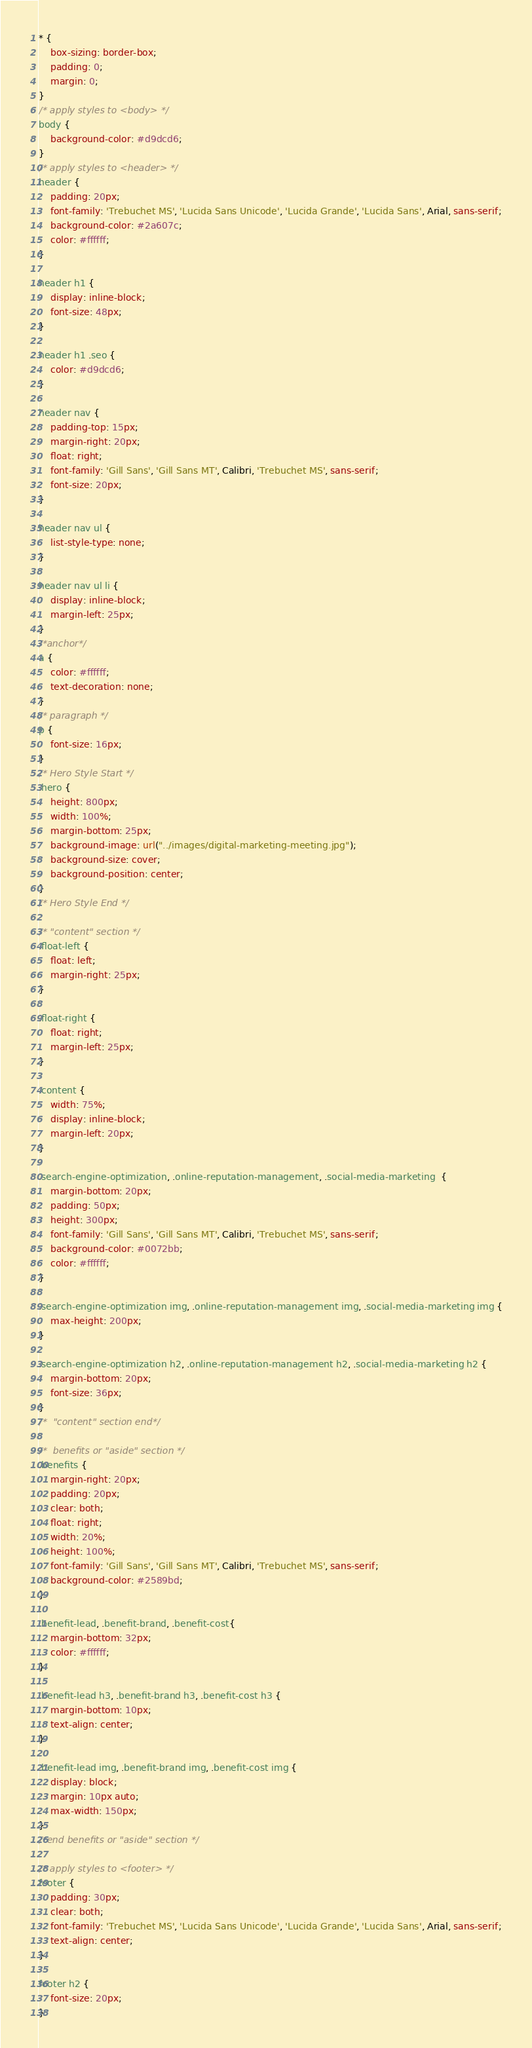Convert code to text. <code><loc_0><loc_0><loc_500><loc_500><_CSS_>* {
    box-sizing: border-box;
    padding: 0;
    margin: 0;
}
/* apply styles to <body> */
body {
    background-color: #d9dcd6;
}
/* apply styles to <header> */
header {
    padding: 20px;
    font-family: 'Trebuchet MS', 'Lucida Sans Unicode', 'Lucida Grande', 'Lucida Sans', Arial, sans-serif;
    background-color: #2a607c;
    color: #ffffff;
}

header h1 {
    display: inline-block;
    font-size: 48px;
}

header h1 .seo {
    color: #d9dcd6;
}

header nav {
    padding-top: 15px;
    margin-right: 20px;
    float: right;
    font-family: 'Gill Sans', 'Gill Sans MT', Calibri, 'Trebuchet MS', sans-serif;
    font-size: 20px;
}

header nav ul {
    list-style-type: none;
}

header nav ul li {
    display: inline-block;
    margin-left: 25px;
}
/*anchor*/
a {
    color: #ffffff;
    text-decoration: none;
}
/* paragraph */
p {
    font-size: 16px;
}
/* Hero Style Start */
.hero {
    height: 800px;
    width: 100%;
    margin-bottom: 25px;
    background-image: url("../images/digital-marketing-meeting.jpg");
    background-size: cover;
    background-position: center;
}
/* Hero Style End */

/* "content" section */ 
.float-left {
    float: left;
    margin-right: 25px;
}

.float-right {
    float: right;
    margin-left: 25px;
}

.content {
    width: 75%;
    display: inline-block;
    margin-left: 20px;
}

.search-engine-optimization, .online-reputation-management, .social-media-marketing  {
    margin-bottom: 20px;
    padding: 50px;
    height: 300px;
    font-family: 'Gill Sans', 'Gill Sans MT', Calibri, 'Trebuchet MS', sans-serif;
    background-color: #0072bb;
    color: #ffffff;
}

.search-engine-optimization img, .online-reputation-management img, .social-media-marketing img {
    max-height: 200px;
}

.search-engine-optimization h2, .online-reputation-management h2, .social-media-marketing h2 {
    margin-bottom: 20px;
    font-size: 36px;
}
/*  "content" section end*/ 

/*  benefits or "aside" section */
.benefits {
    margin-right: 20px;
    padding: 20px;
    clear: both;
    float: right;
    width: 20%;
    height: 100%;
    font-family: 'Gill Sans', 'Gill Sans MT', Calibri, 'Trebuchet MS', sans-serif;
    background-color: #2589bd;
}

.benefit-lead, .benefit-brand, .benefit-cost{
    margin-bottom: 32px;
    color: #ffffff;
}

.benefit-lead h3, .benefit-brand h3, .benefit-cost h3 {
    margin-bottom: 10px;
    text-align: center;
}

.benefit-lead img, .benefit-brand img, .benefit-cost img {
    display: block;
    margin: 10px auto;
    max-width: 150px;
}
/*end benefits or "aside" section */

/* apply styles to <footer> */
footer {
    padding: 30px;
    clear: both;
    font-family: 'Trebuchet MS', 'Lucida Sans Unicode', 'Lucida Grande', 'Lucida Sans', Arial, sans-serif;
    text-align: center;
}

footer h2 {
    font-size: 20px;
}
</code> 